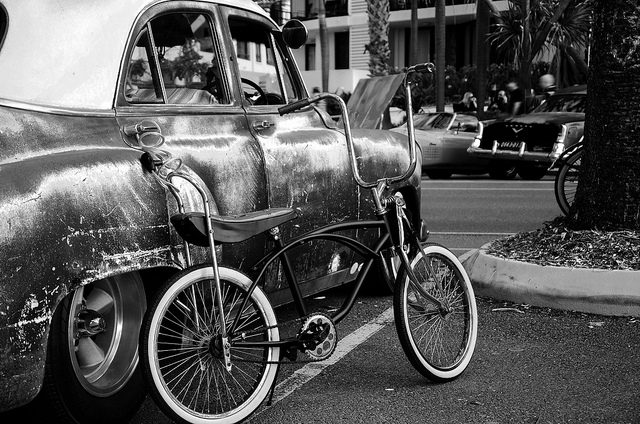Could you describe the setting or location of this image? The photo seems to be taken on a city street, judging by the presence of parallel parked cars and a building in the background, creating an urban scene likely in a downtown area or a busy neighborhood. 